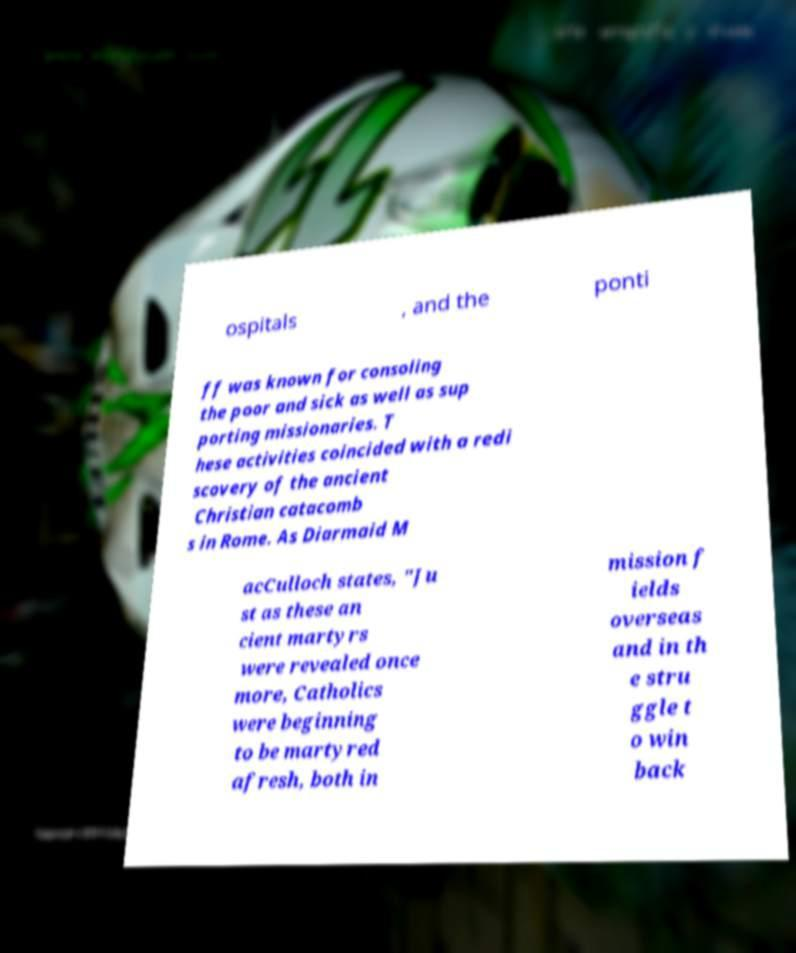I need the written content from this picture converted into text. Can you do that? ospitals , and the ponti ff was known for consoling the poor and sick as well as sup porting missionaries. T hese activities coincided with a redi scovery of the ancient Christian catacomb s in Rome. As Diarmaid M acCulloch states, "Ju st as these an cient martyrs were revealed once more, Catholics were beginning to be martyred afresh, both in mission f ields overseas and in th e stru ggle t o win back 